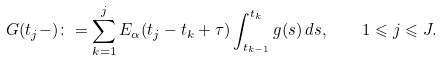Convert formula to latex. <formula><loc_0><loc_0><loc_500><loc_500>G ( t _ { j } - ) \colon = \sum _ { k = 1 } ^ { j } E _ { \alpha } ( t _ { j } - t _ { k } + \tau ) \int _ { t _ { k - 1 } } ^ { t _ { k } } g ( s ) \, d s , \quad 1 \leqslant j \leqslant J .</formula> 